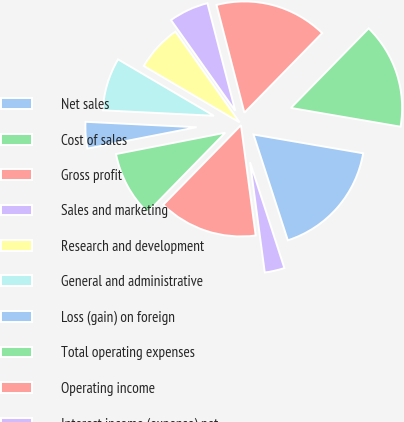<chart> <loc_0><loc_0><loc_500><loc_500><pie_chart><fcel>Net sales<fcel>Cost of sales<fcel>Gross profit<fcel>Sales and marketing<fcel>Research and development<fcel>General and administrative<fcel>Loss (gain) on foreign<fcel>Total operating expenses<fcel>Operating income<fcel>Interest income (expense) net<nl><fcel>17.31%<fcel>15.38%<fcel>16.35%<fcel>5.77%<fcel>6.73%<fcel>7.69%<fcel>3.85%<fcel>9.62%<fcel>14.42%<fcel>2.88%<nl></chart> 